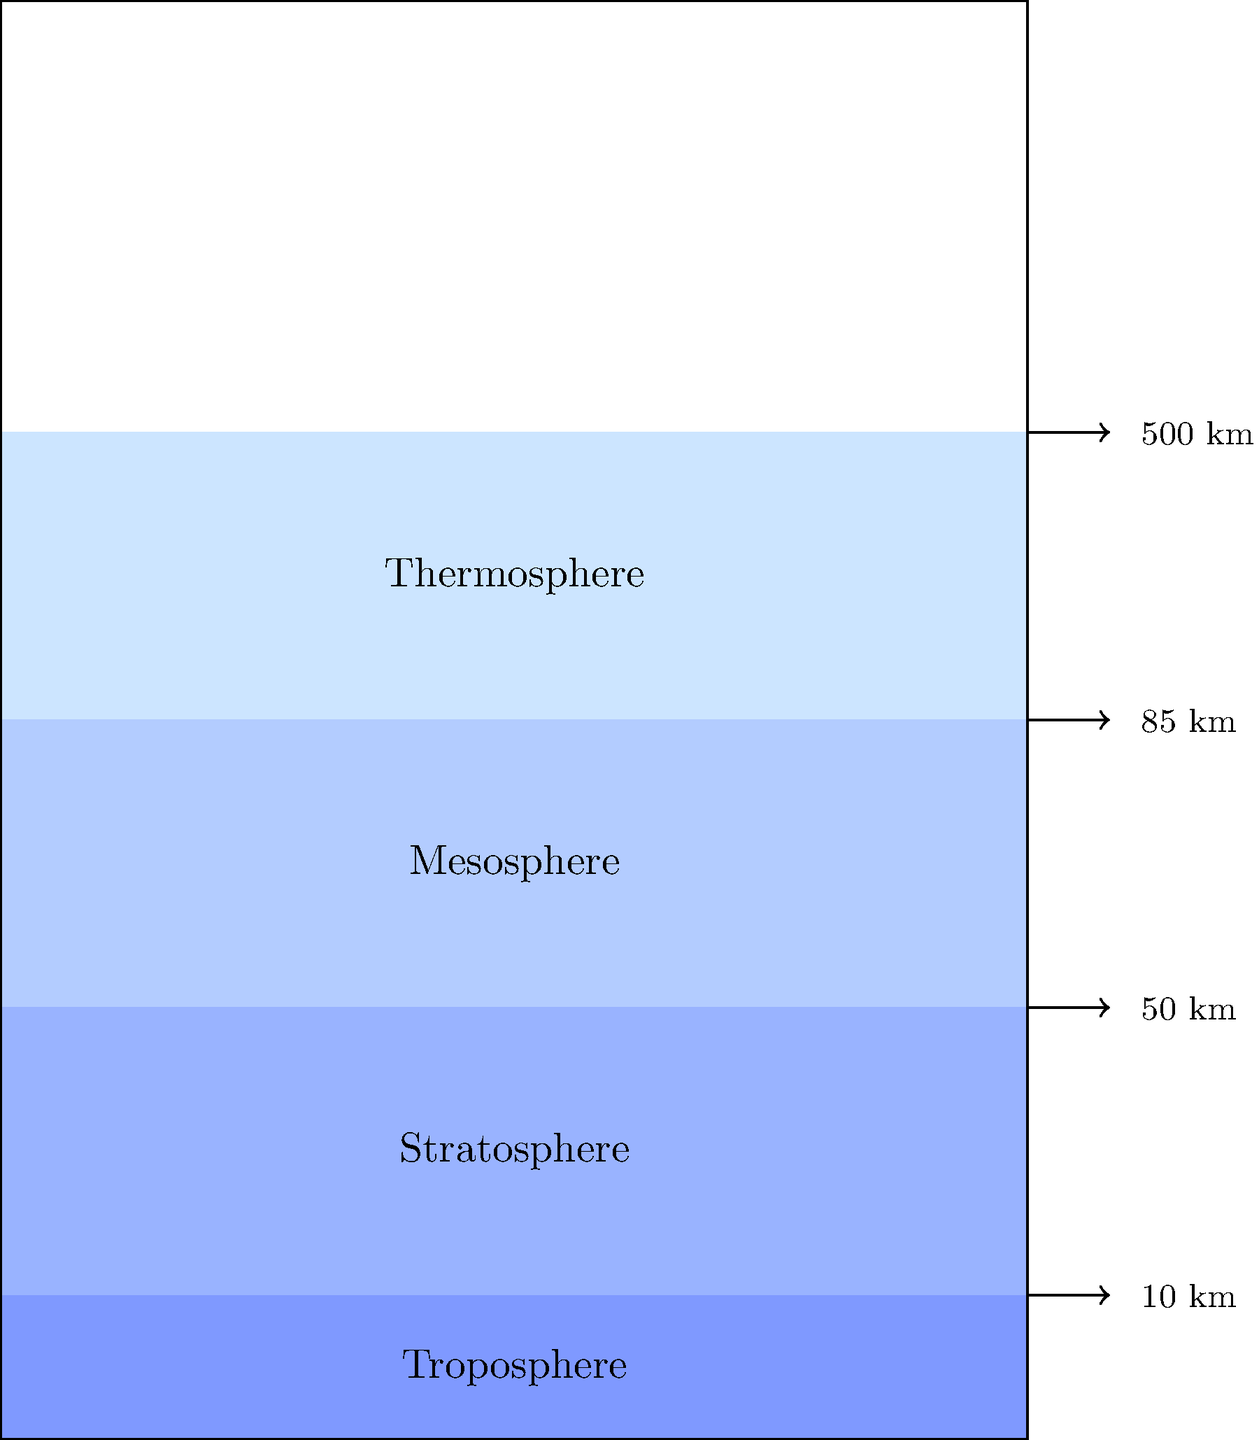In the diagram of Earth's atmosphere, which layer is responsible for most weather phenomena and contains approximately 75% of the atmosphere's mass? To answer this question, let's analyze the layers of Earth's atmosphere from bottom to top:

1. Troposphere (0-10 km):
   - This is the lowest layer of the atmosphere.
   - It contains about 75-80% of the atmosphere's mass.
   - Most weather phenomena occur in this layer.
   - Temperature decreases with altitude in this layer.

2. Stratosphere (10-50 km):
   - Contains the ozone layer.
   - Temperature increases with altitude due to ozone absorption of UV radiation.
   - Relatively stable with little vertical mixing.

3. Mesosphere (50-85 km):
   - Temperature decreases with altitude.
   - Coldest layer of the atmosphere.
   - Meteors often burn up in this layer.

4. Thermosphere (85-500+ km):
   - Temperature increases with altitude due to absorption of solar radiation.
   - Very thin air in this layer.
   - Aurora phenomena occur here.

Based on the information provided, the troposphere is responsible for most weather phenomena and contains approximately 75% of the atmosphere's mass.
Answer: Troposphere 